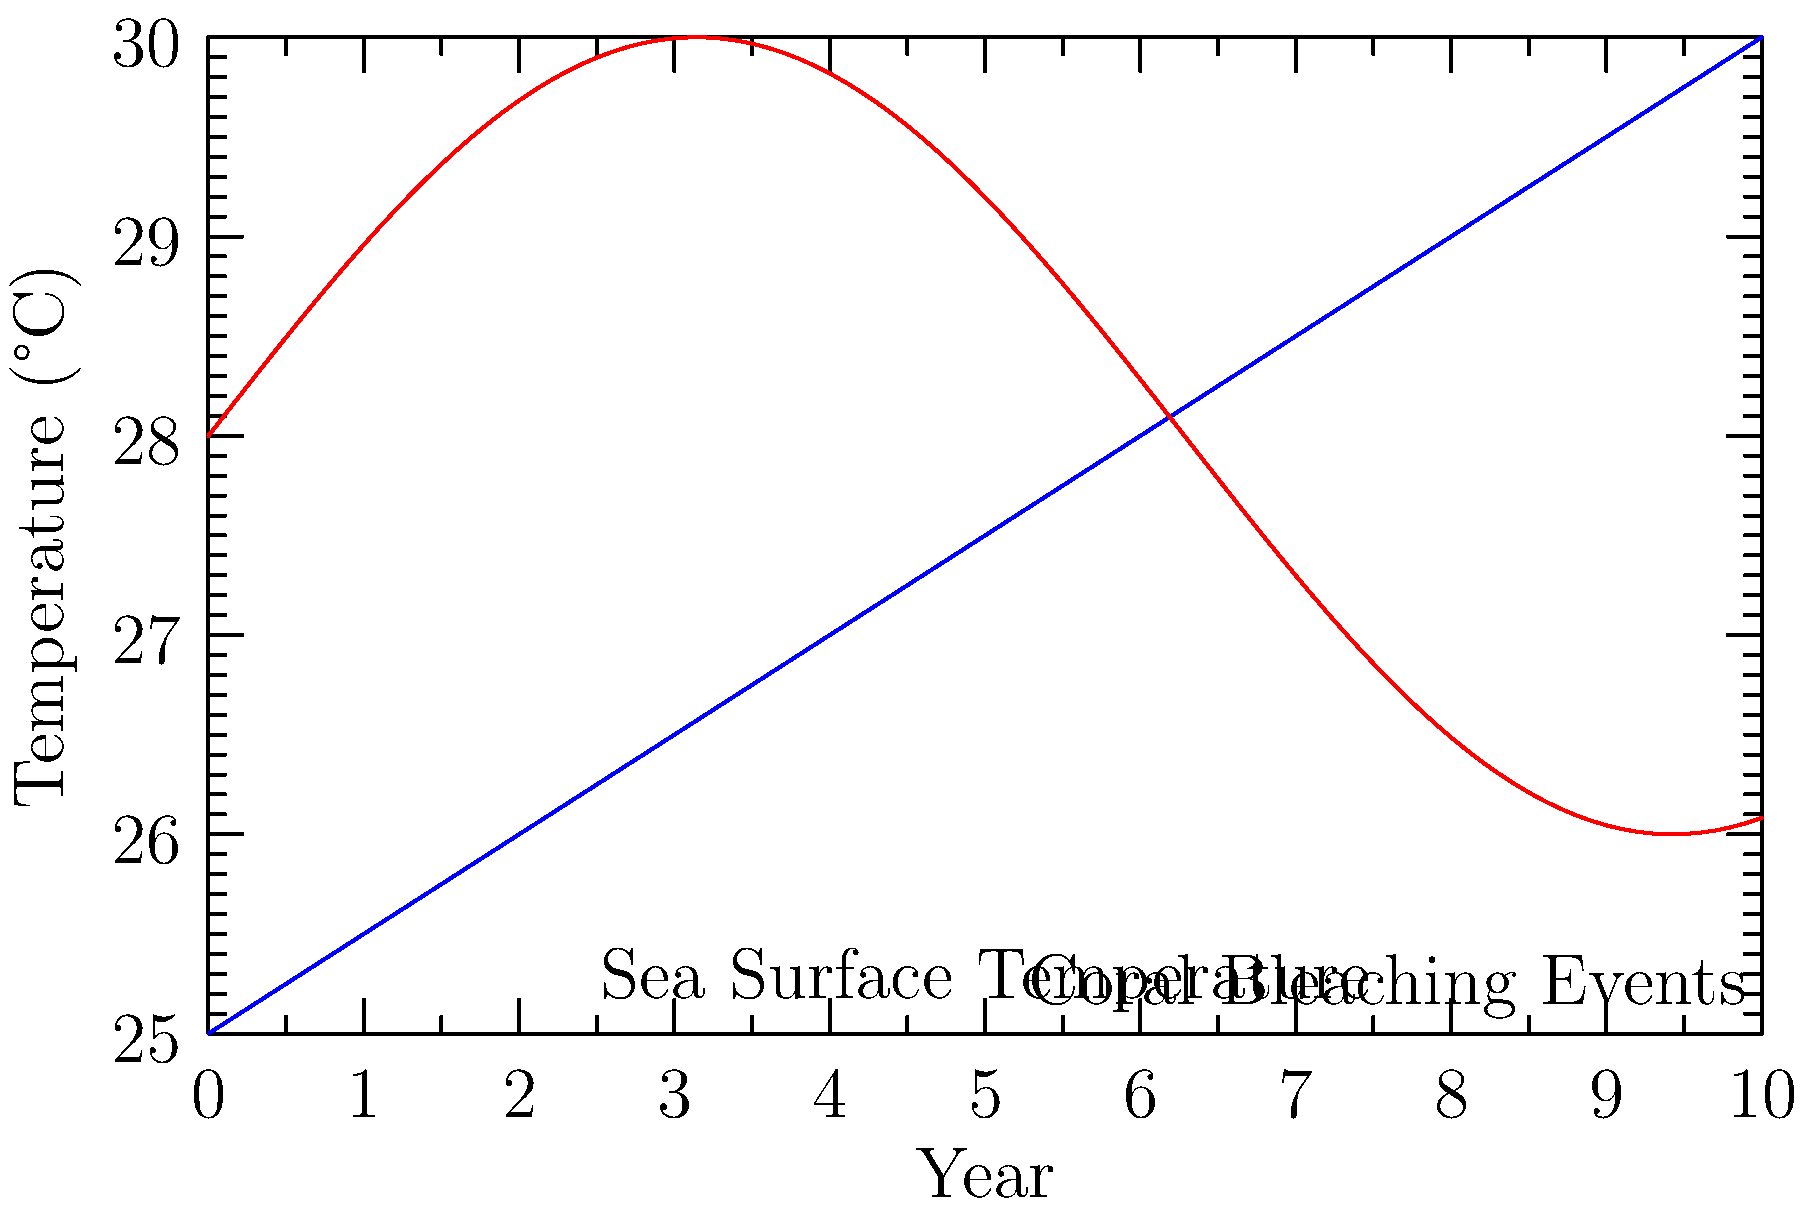Based on the graph showing sea surface temperature (SST) and coral bleaching events over a 10-year period, what conclusion can be drawn about the relationship between SST and coral bleaching, and how might this impact the economic and ecological value of coral reefs? To answer this question, let's analyze the graph step-by-step:

1. Observe the blue line representing sea surface temperature (SST):
   - It shows a clear upward trend over the 10-year period.
   - The increase appears to be roughly linear.

2. Examine the red line representing coral bleaching events:
   - It shows a cyclical pattern with increasing intensity over time.
   - The peaks of bleaching events seem to coincide with higher SST values.

3. Relationship between SST and coral bleaching:
   - As SST increases, the frequency and intensity of bleaching events also increase.
   - This suggests a positive correlation between SST and coral bleaching.

4. Impact on economic and ecological value:
   - Coral reefs provide significant economic benefits through tourism, fisheries, and coastal protection.
   - They also support rich biodiversity and play a crucial role in marine ecosystems.
   - Increased bleaching events can lead to coral death and reef degradation.
   - This degradation can result in:
     a) Reduced tourism revenue
     b) Declining fish populations and fisheries
     c) Decreased coastal protection from storms and erosion
     d) Loss of biodiversity and ecosystem services

5. Long-term implications:
   - If the trend continues, it could lead to irreversible damage to coral reef ecosystems.
   - This would have severe economic consequences for coastal communities and nations relying on reef-related industries.
   - It would also result in significant ecological losses, affecting marine biodiversity and climate regulation.

In conclusion, the graph indicates a strong positive correlation between rising sea surface temperatures and increased coral bleaching events, which poses a significant threat to the economic and ecological value of coral reefs.
Answer: Positive correlation between SST and bleaching, threatening reef economic and ecological value. 